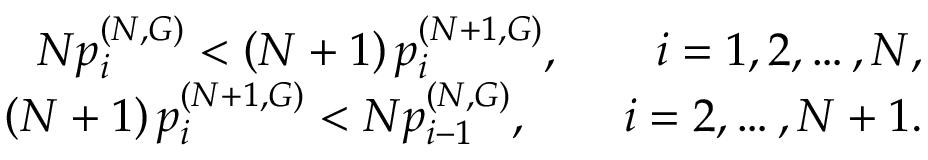<formula> <loc_0><loc_0><loc_500><loc_500>\begin{array} { r } { N p _ { i } ^ { ( N , G ) } < \left ( N + 1 \right ) p _ { i } ^ { ( N + 1 , G ) } , \quad i = 1 , 2 , \dots , N , } \\ { \left ( N + 1 \right ) p _ { i } ^ { ( N + 1 , G ) } < N p _ { i - 1 } ^ { ( N , G ) } , \quad i = 2 , \dots , N + 1 . } \end{array}</formula> 